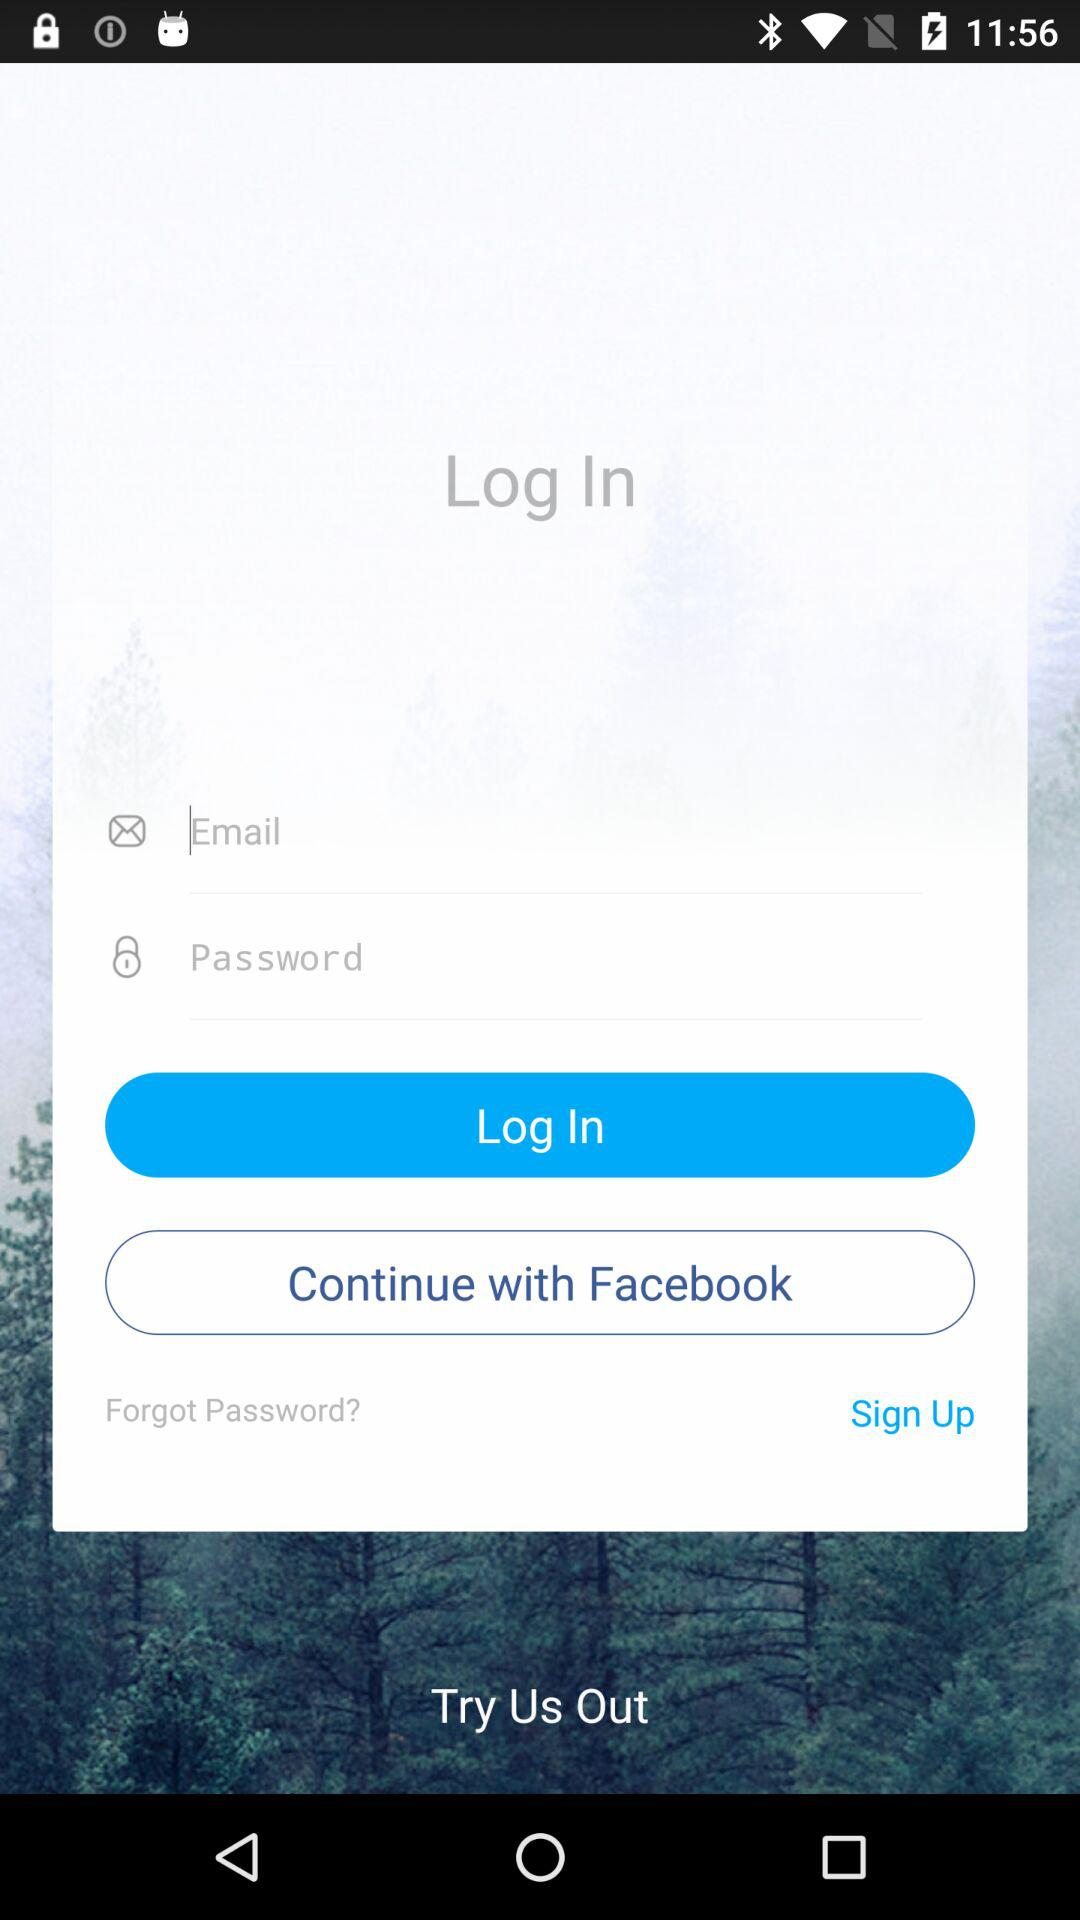Which account can be used to log in? The accounts that can be used to log in are "Email" and "Facebook". 